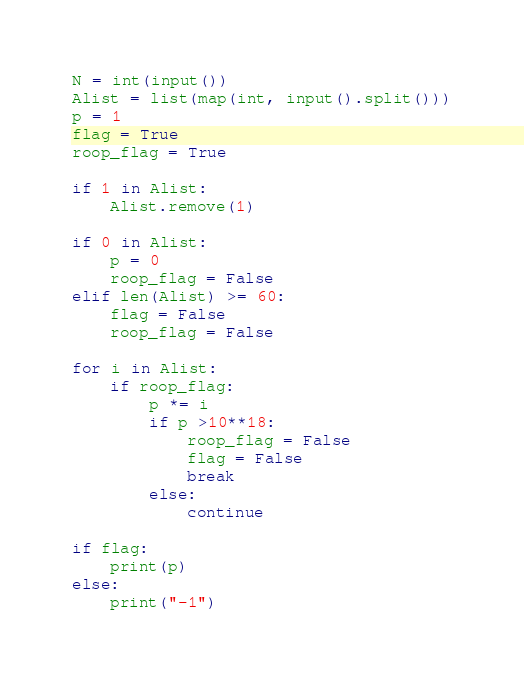<code> <loc_0><loc_0><loc_500><loc_500><_Python_>N = int(input())
Alist = list(map(int, input().split()))
p = 1
flag = True
roop_flag = True

if 1 in Alist:
    Alist.remove(1)

if 0 in Alist:
    p = 0
    roop_flag = False
elif len(Alist) >= 60:
    flag = False
    roop_flag = False
    
for i in Alist:
    if roop_flag:
        p *= i
        if p >10**18:
            roop_flag = False
            flag = False
            break
        else:
            continue
    
if flag:
    print(p)
else:
    print("-1")</code> 